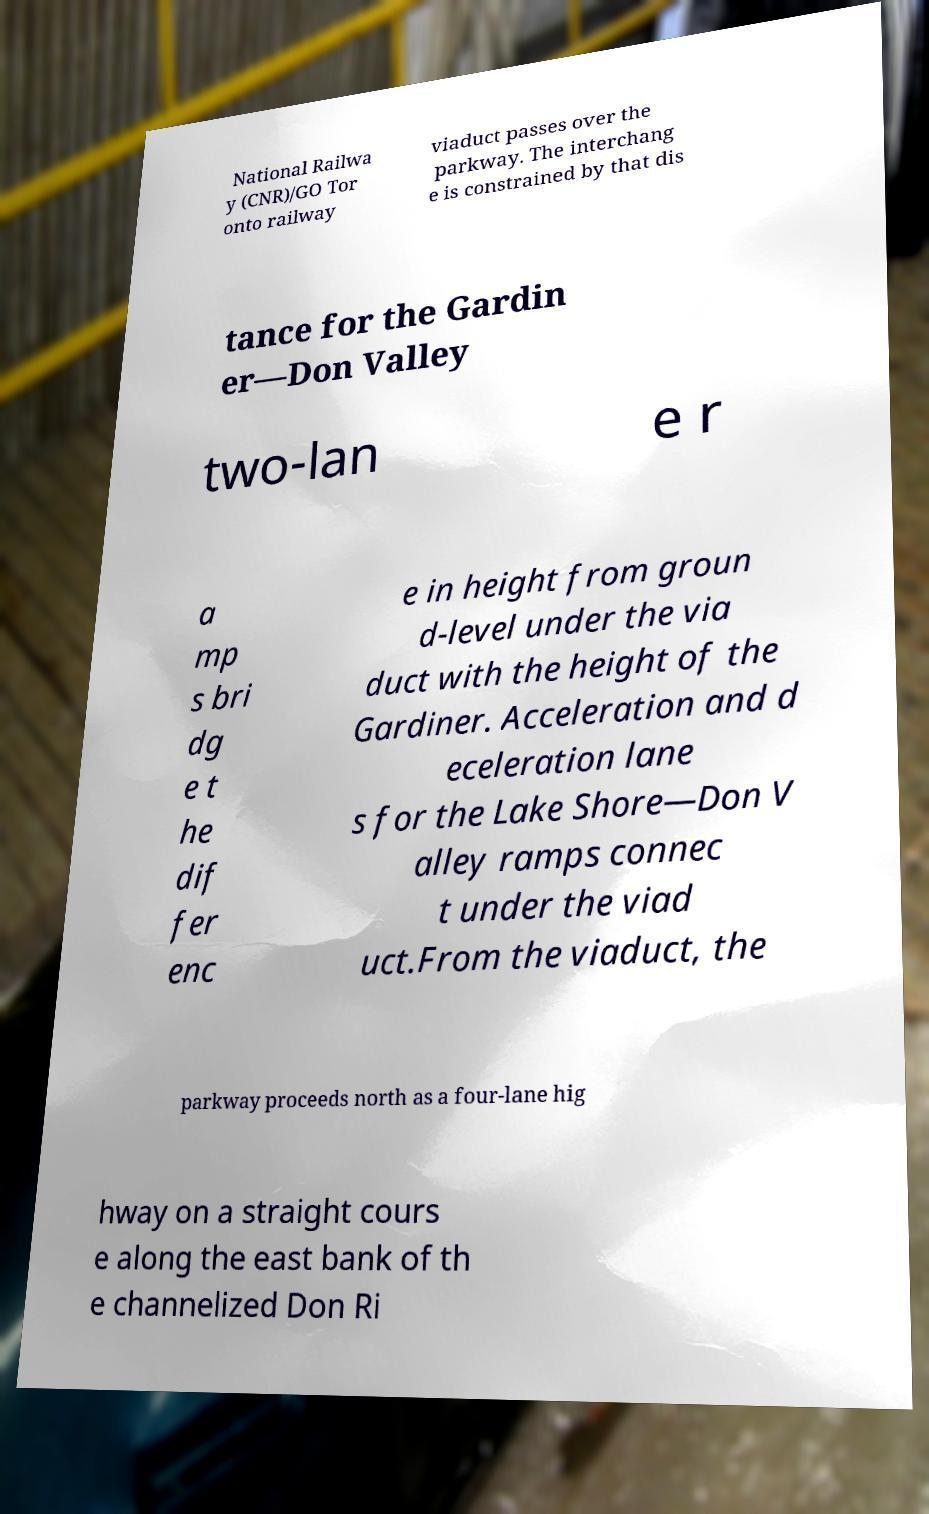Could you extract and type out the text from this image? National Railwa y (CNR)/GO Tor onto railway viaduct passes over the parkway. The interchang e is constrained by that dis tance for the Gardin er—Don Valley two-lan e r a mp s bri dg e t he dif fer enc e in height from groun d-level under the via duct with the height of the Gardiner. Acceleration and d eceleration lane s for the Lake Shore—Don V alley ramps connec t under the viad uct.From the viaduct, the parkway proceeds north as a four-lane hig hway on a straight cours e along the east bank of th e channelized Don Ri 